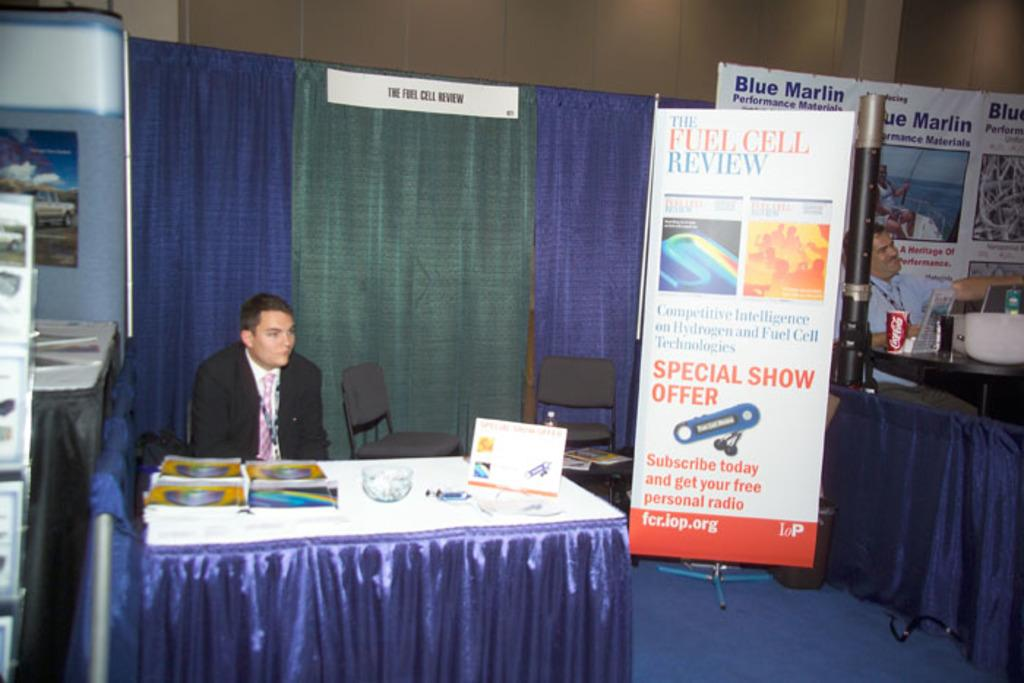<image>
Offer a succinct explanation of the picture presented. A man is sitting behind a booth at a trade show by a sign that says The Fuel Cell Review. 